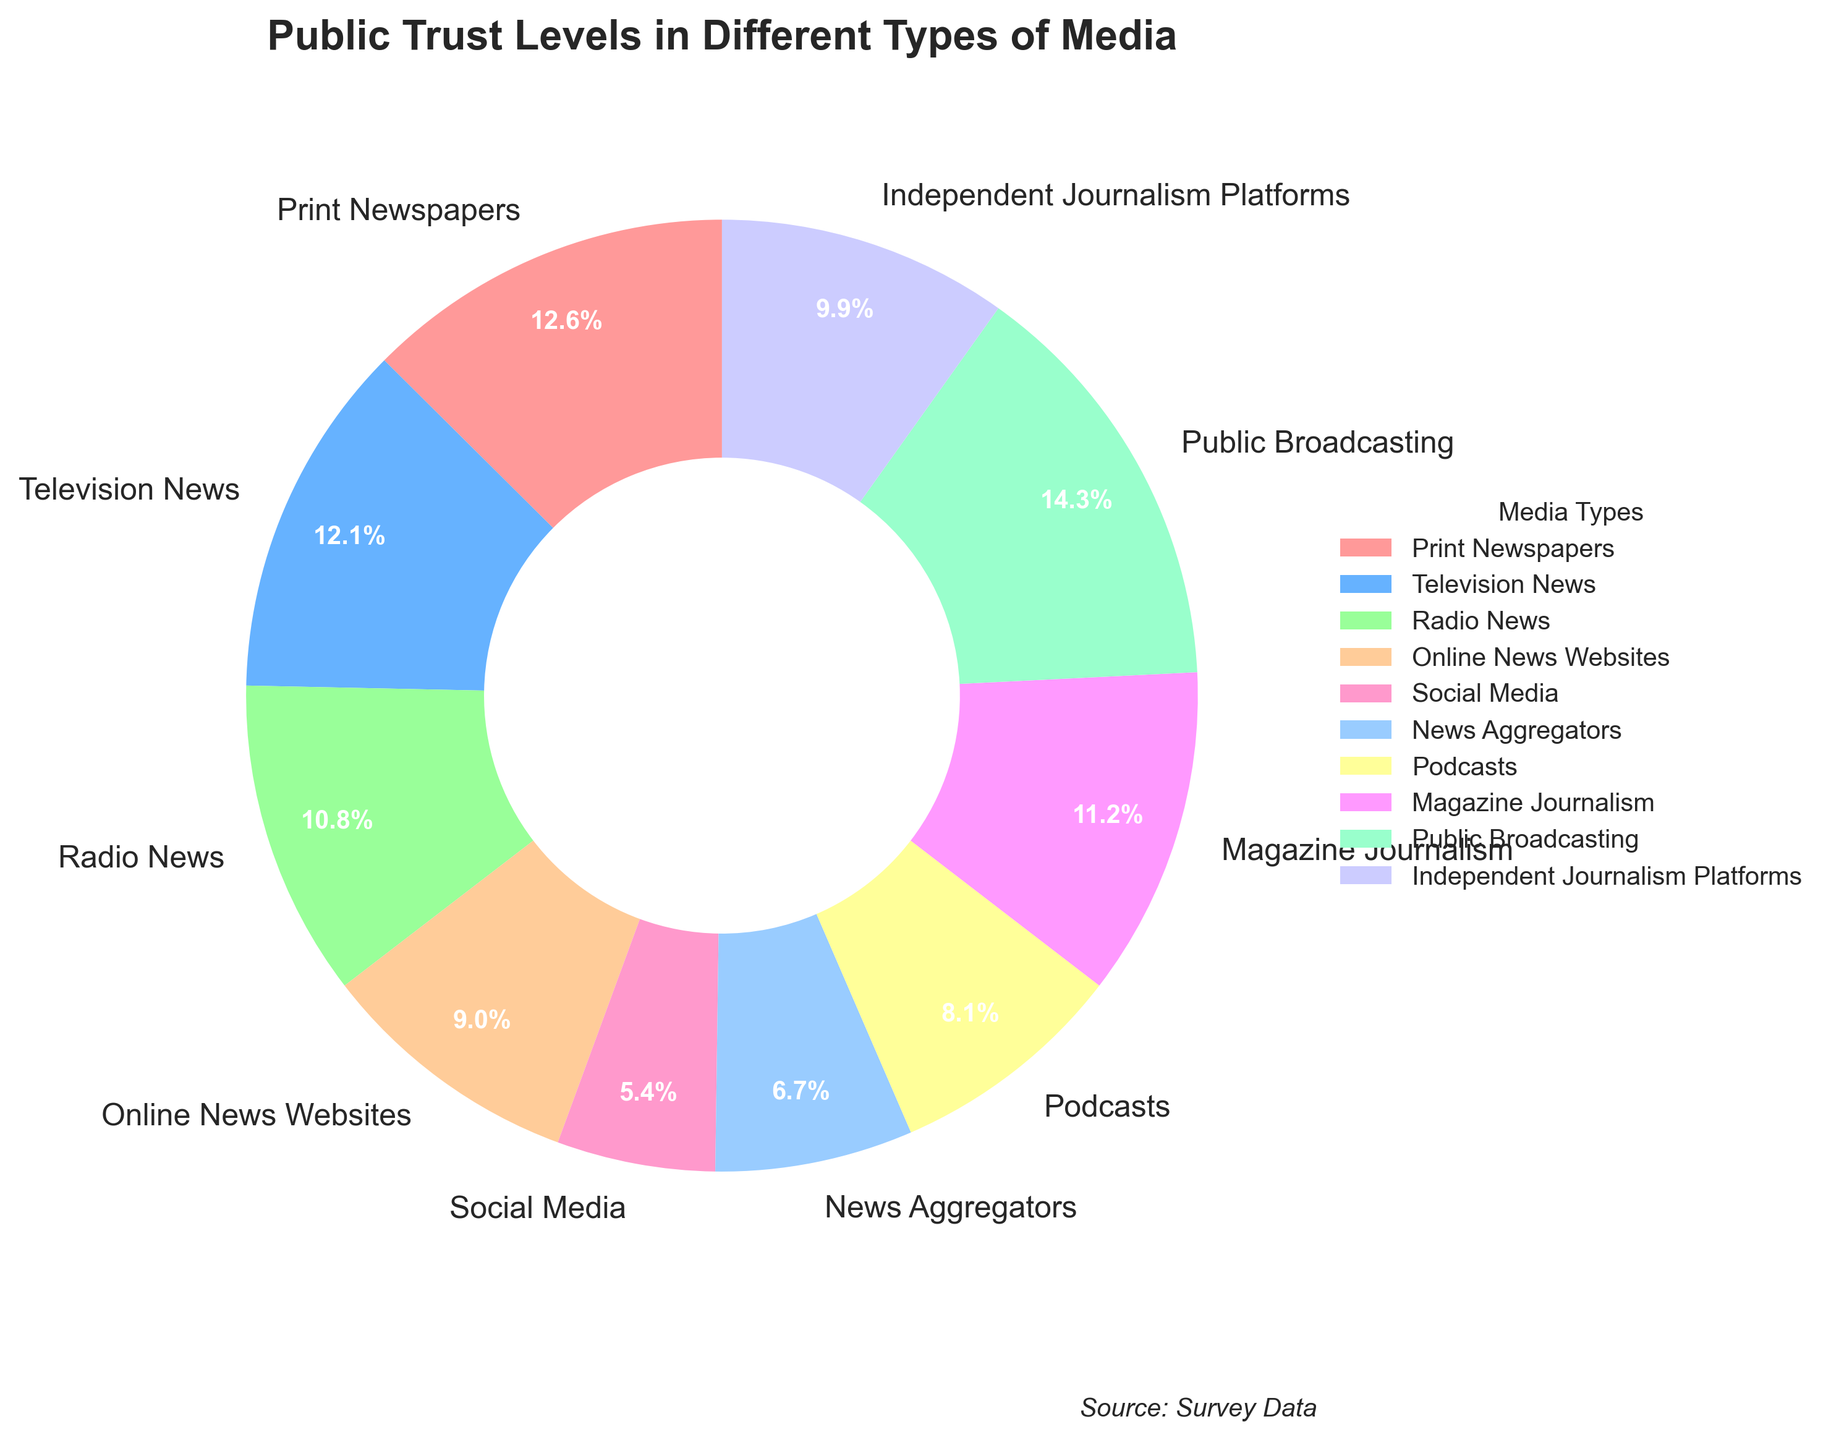What's the media type with the highest public trust level? The media type with the highest public trust level can be identified by looking at the wedge with the largest percentage in the pie chart. The public trust level is marked as 32% for Public Broadcasting.
Answer: Public Broadcasting Which media types have public trust levels below 20%? Look at the wedges corresponding to each media type and find those with percentages less than 20%. These media types are Online News Websites (20%), Social Media (12%), News Aggregators (15%), and Podcasts (18%).
Answer: Online News Websites, Social Media, News Aggregators, Podcasts What's the sum of the public trust levels for Print Newspapers and Television News? Locate the wedges for Print Newspapers (28%) and Television News (27%). Adding these values gives 28% + 27% = 55%.
Answer: 55% Which media type has a higher public trust level, Radio News or Magazine Journalism? Compare the wedges for Radio News (24%) and Magazine Journalism (25%). Magazine Journalism has a higher percentage.
Answer: Magazine Journalism How much more trust does Public Broadcasting have compared to Social Media? Locate the wedges for Public Broadcasting (32%) and Social Media (12%). Subtract the smaller percentage from the larger one: 32% - 12% = 20%.
Answer: 20% What is the average public trust level for Independent Journalism Platforms, Podcasts, and Online News Websites? Locate the wedges for Independent Journalism Platforms (22%), Podcasts (18%), and Online News Websites (20%). Add these values and divide by the number of media types: (22% + 18% + 20%) / 3 = 60% / 3 = 20%.
Answer: 20% Which colors correspond to the media types with the highest and lowest trust levels, respectively? The highest trust level is Public Broadcasting (32%), represented by the light blue wedge. The lowest trust level is Social Media (12%), represented by the pink wedge.
Answer: Light blue, Pink What's the difference in public trust levels between Television News and News Aggregators? Locate the wedges for Television News (27%) and News Aggregators (15%). Subtract the smaller percentage from the larger one: 27% - 15% = 12%.
Answer: 12% Between Public Broadcasting and Print Newspapers, which has a narrower wedge and by how much? Locate the wedges for Public Broadcasting (32%) and Print Newspapers (28%). Subtract the smaller percentage from the larger one: 32% - 28% = 4%.
Answer: Print Newspapers, 4% What is the average public trust level for all media types represented in the pie chart? Add all the trust levels and divide by the number of media types: (28% + 27% + 24% + 20% + 12% + 15% + 18% + 25% + 32% + 22%) / 10 = 223% / 10 = 22.3%.
Answer: 22.3% 